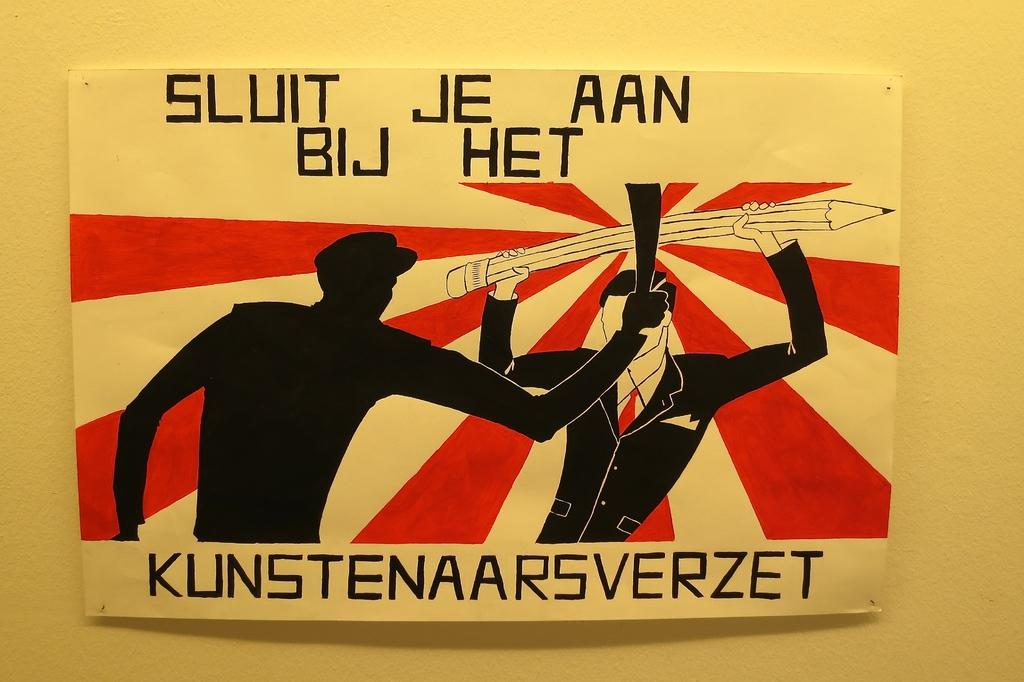<image>
Present a compact description of the photo's key features. A poster of a man defending himself from a sword with a large pencil has German writing on it. 